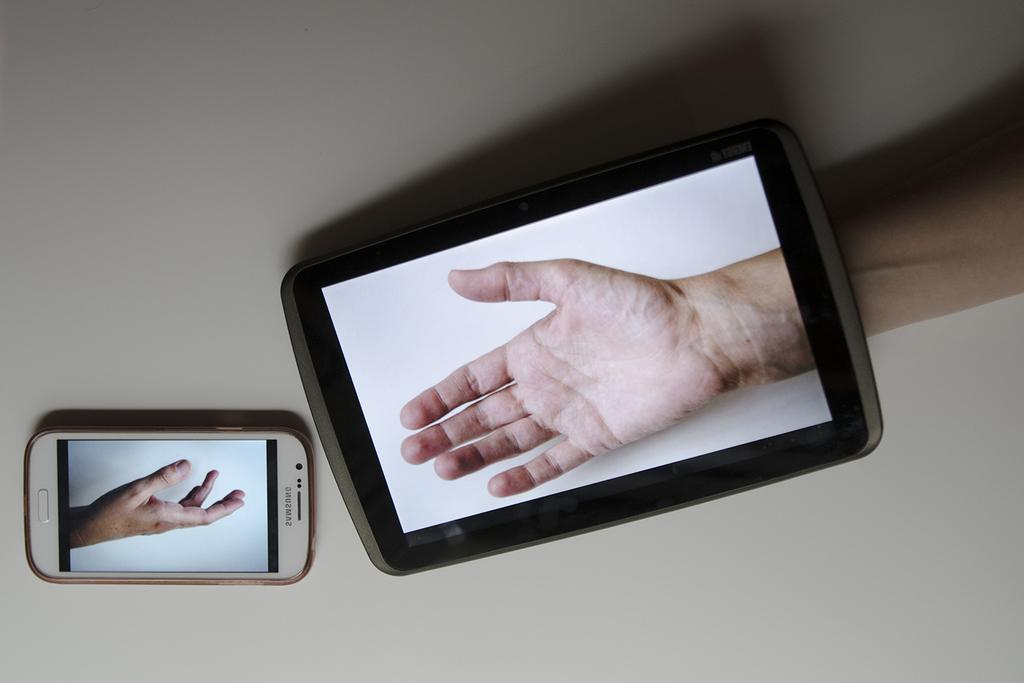How many mobiles can be seen in the image? There are two mobiles in the image. Can you describe any other elements in the image? Yes, there is a human hand in the image. What type of tank is visible in the image? There is no tank present in the image. 